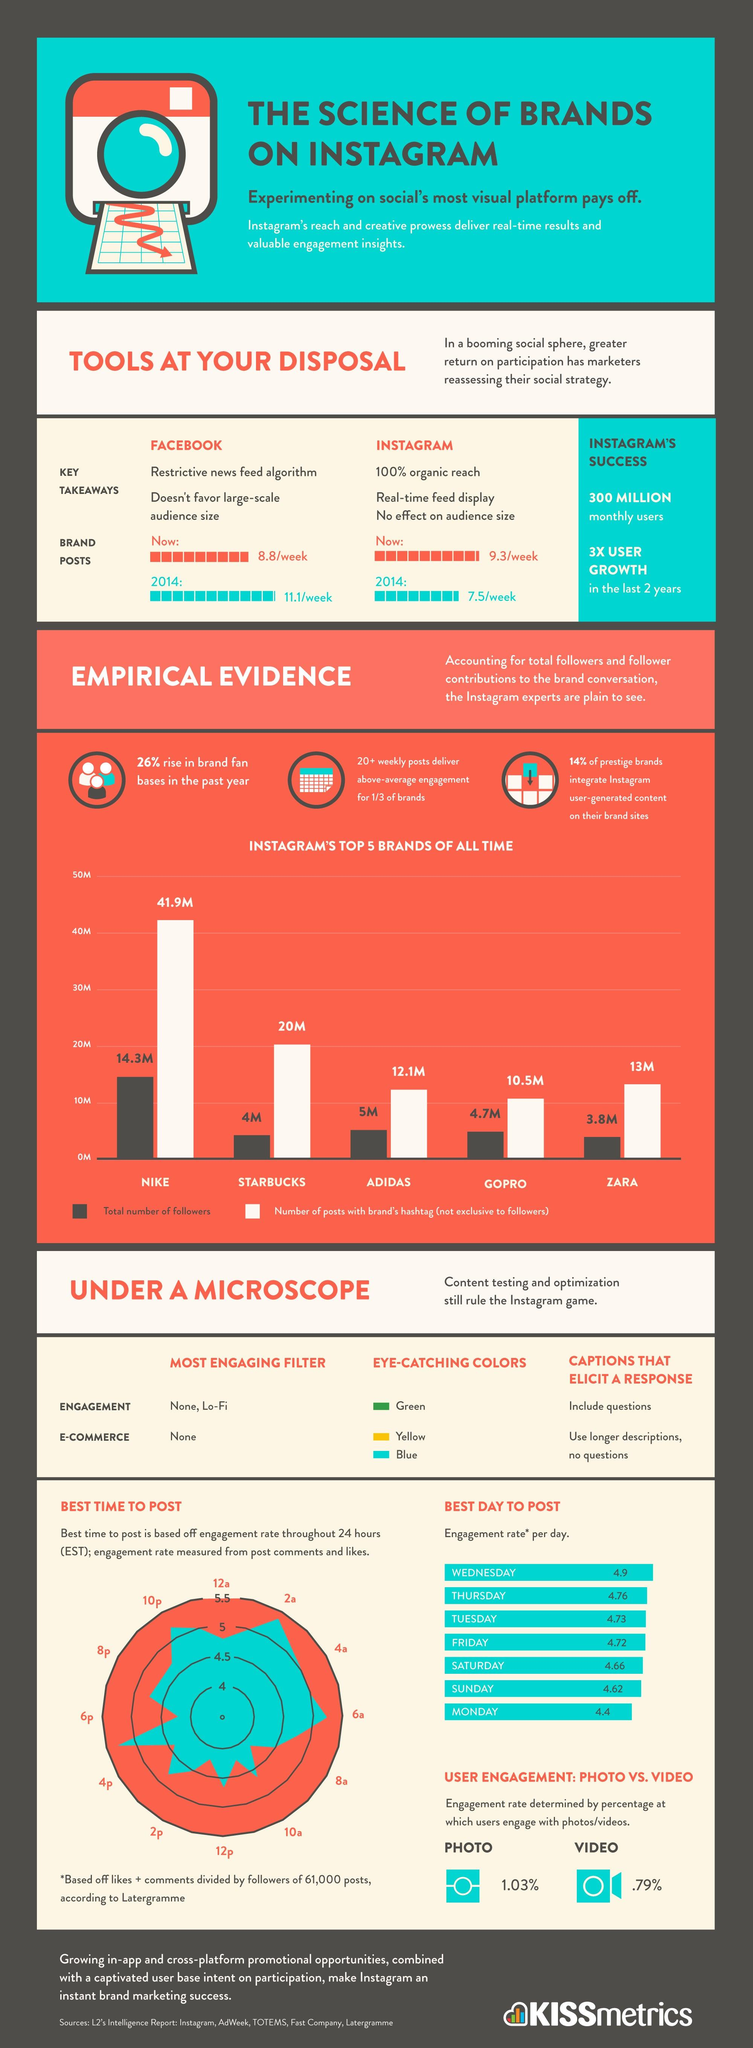Specify some key components in this picture. The attention-grabbing colors include green, yellow, and blue. Wednesday is the best day to post. 